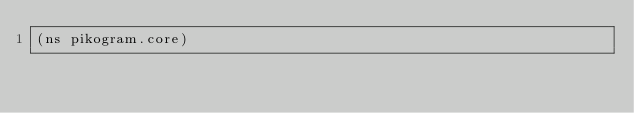<code> <loc_0><loc_0><loc_500><loc_500><_Clojure_>(ns pikogram.core)
</code> 